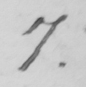What is written in this line of handwriting? 7 . 